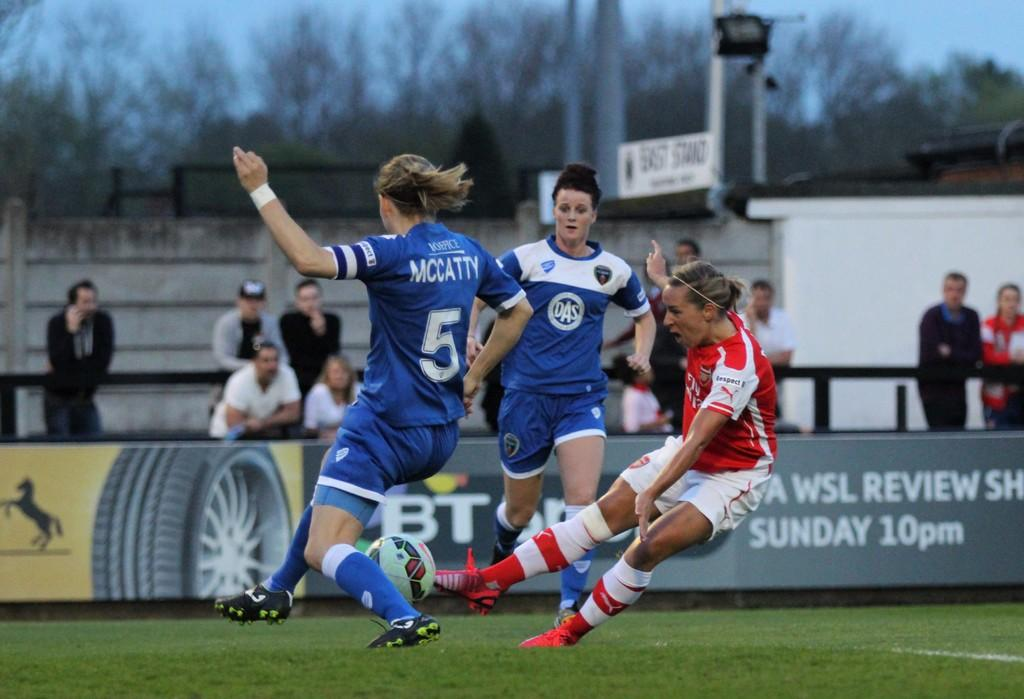Provide a one-sentence caption for the provided image. a few soccer players with one girl wearing the number 5. 